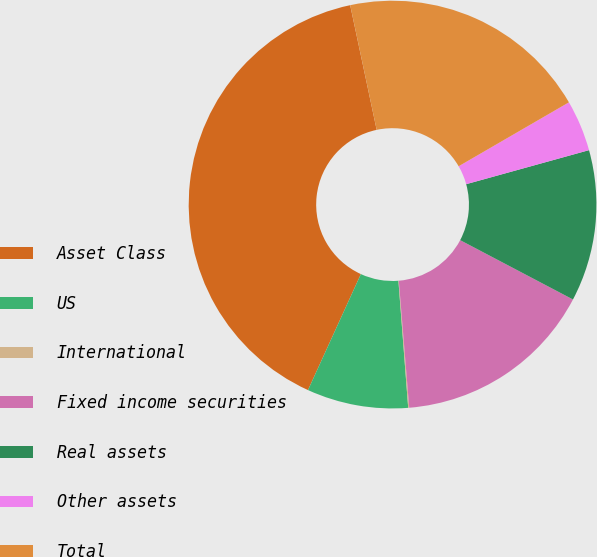Convert chart. <chart><loc_0><loc_0><loc_500><loc_500><pie_chart><fcel>Asset Class<fcel>US<fcel>International<fcel>Fixed income securities<fcel>Real assets<fcel>Other assets<fcel>Total<nl><fcel>39.86%<fcel>8.03%<fcel>0.08%<fcel>15.99%<fcel>12.01%<fcel>4.06%<fcel>19.97%<nl></chart> 